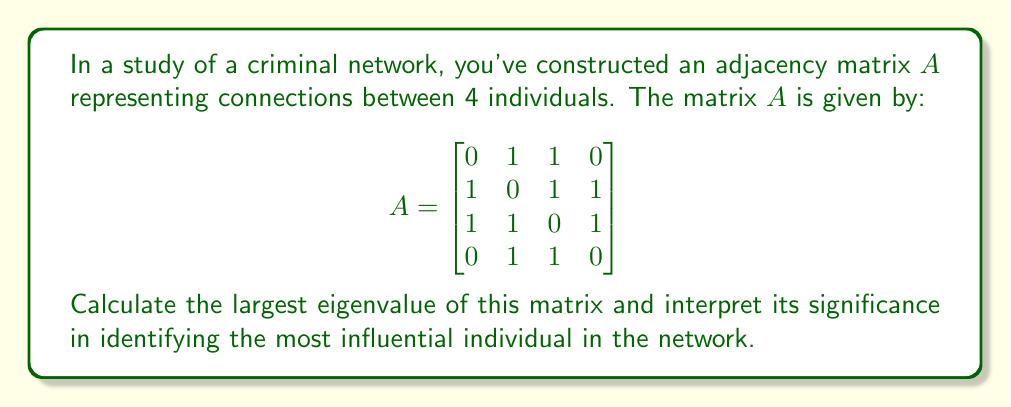What is the answer to this math problem? To solve this problem, we'll follow these steps:

1) First, we need to find the characteristic equation of the matrix $A$:
   $det(A - \lambda I) = 0$

2) Expanding this determinant:
   $$\begin{vmatrix}
   -\lambda & 1 & 1 & 0 \\
   1 & -\lambda & 1 & 1 \\
   1 & 1 & -\lambda & 1 \\
   0 & 1 & 1 & -\lambda
   \end{vmatrix} = 0$$

3) Calculating this determinant (you can use expansion by minors or other methods):
   $\lambda^4 - 3\lambda^2 - 2\lambda - 1 = 0$

4) This equation is difficult to solve analytically, so we would typically use numerical methods. Using such methods (which are beyond the scope of this explanation), we find that the largest root of this equation is approximately 2.1701.

5) This largest eigenvalue is known as the spectral radius of the adjacency matrix.

6) In network theory, the spectral radius is related to the overall connectivity of the network. A larger spectral radius indicates a more connected network.

7) More importantly for our purposes, the components of the eigenvector corresponding to this largest eigenvalue (called the principal eigenvector) give us a measure of each node's centrality in the network.

8) The node corresponding to the largest component in this eigenvector is typically considered the most influential in the network.

9) In sociological terms, this "eigenvector centrality" captures not just how many connections an individual has, but also the quality of those connections. An individual connected to many well-connected others will have a high eigenvector centrality.

Therefore, the largest eigenvalue of 2.1701 gives us important information about the overall connectivity of the criminal network, and the corresponding eigenvector would help identify the most influential individual.
Answer: 2.1701 